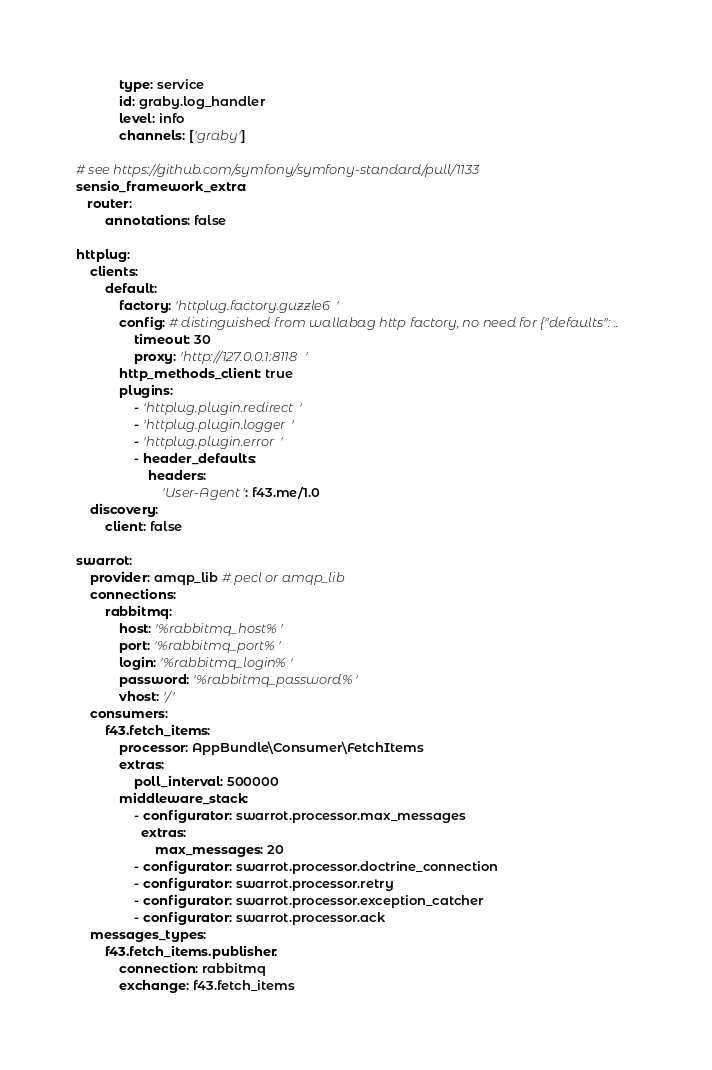Convert code to text. <code><loc_0><loc_0><loc_500><loc_500><_YAML_>            type: service
            id: graby.log_handler
            level: info
            channels: ['graby']

# see https://github.com/symfony/symfony-standard/pull/1133
sensio_framework_extra:
   router:
        annotations: false

httplug:
    clients:
        default:
            factory: 'httplug.factory.guzzle6'
            config: # distinguished from wallabag http factory, no need for {"defaults": ..
                timeout: 30
                proxy: 'http://127.0.0.1:8118' 
            http_methods_client: true
            plugins:
                - 'httplug.plugin.redirect'
                - 'httplug.plugin.logger'
                - 'httplug.plugin.error'
                - header_defaults:
                    headers:
                        'User-Agent': f43.me/1.0
    discovery:
        client: false

swarrot:
    provider: amqp_lib # pecl or amqp_lib
    connections:
        rabbitmq:
            host: '%rabbitmq_host%'
            port: '%rabbitmq_port%'
            login: '%rabbitmq_login%'
            password: '%rabbitmq_password%'
            vhost: '/'
    consumers:
        f43.fetch_items:
            processor: AppBundle\Consumer\FetchItems
            extras:
                poll_interval: 500000
            middleware_stack:
                - configurator: swarrot.processor.max_messages
                  extras:
                      max_messages: 20
                - configurator: swarrot.processor.doctrine_connection
                - configurator: swarrot.processor.retry
                - configurator: swarrot.processor.exception_catcher
                - configurator: swarrot.processor.ack
    messages_types:
        f43.fetch_items.publisher:
            connection: rabbitmq
            exchange: f43.fetch_items
</code> 